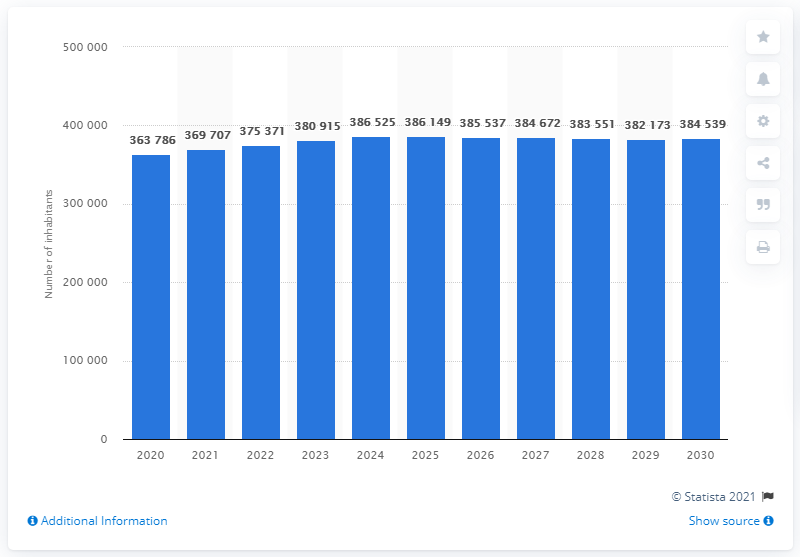What is the estimated population of Iceland by 2030? The estimated population of Iceland by 2030 is projected to be 384,539. This reflects a steady growth trend as shown in the graph, with incremental increases each year leading up to 2030. Understanding these changes is crucial as it impacts national planning and development strategies. 